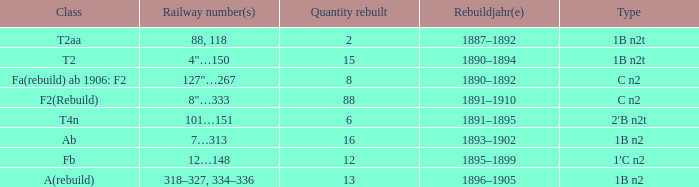What was the Rebuildjahr(e) for the T2AA class? 1887–1892. 